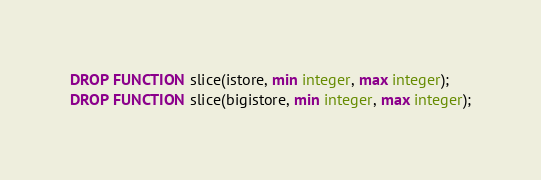<code> <loc_0><loc_0><loc_500><loc_500><_SQL_>DROP FUNCTION slice(istore, min integer, max integer);
DROP FUNCTION slice(bigistore, min integer, max integer);</code> 